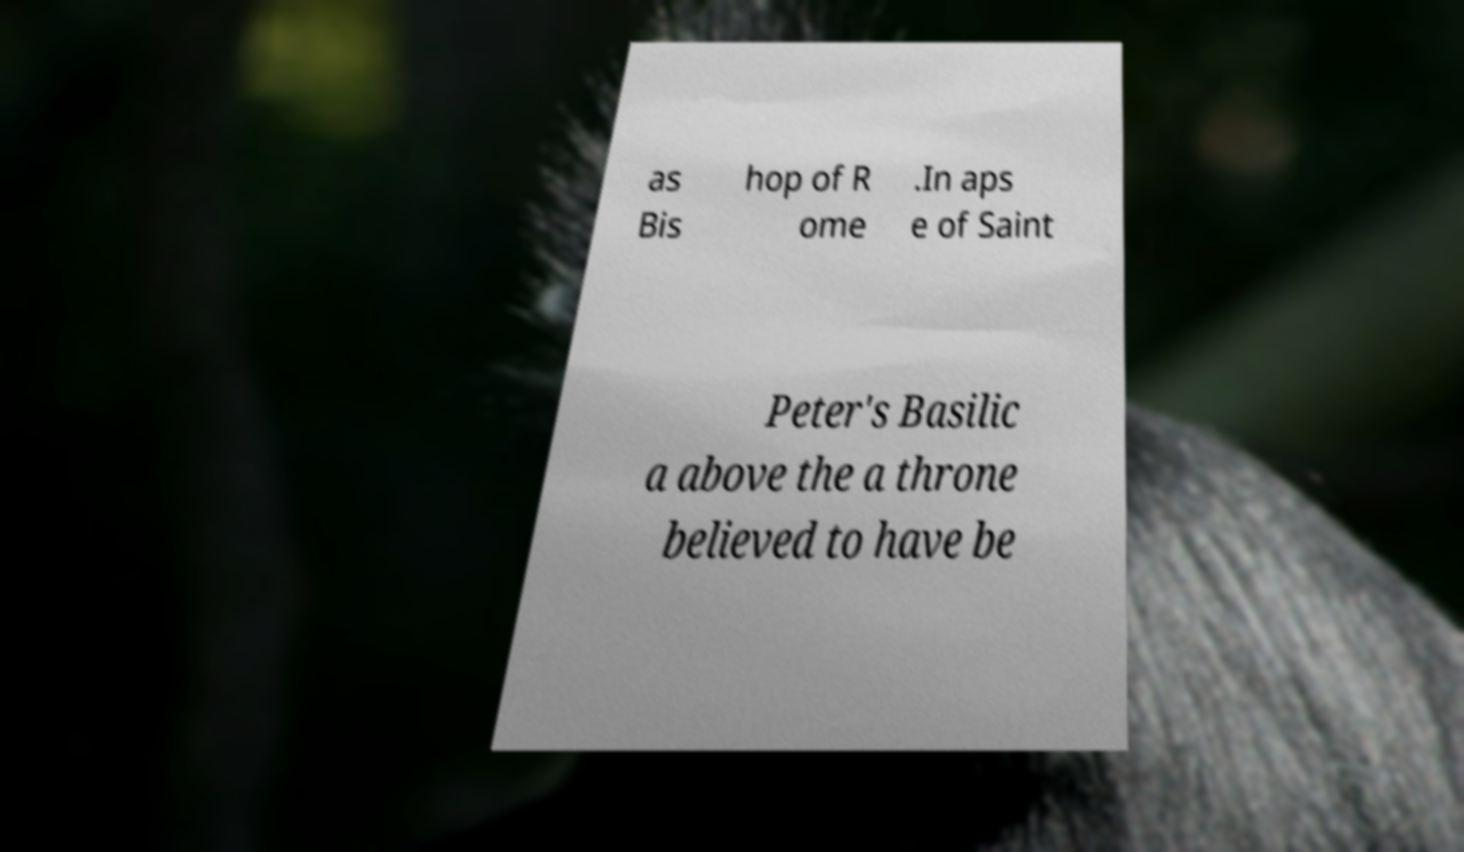There's text embedded in this image that I need extracted. Can you transcribe it verbatim? as Bis hop of R ome .In aps e of Saint Peter's Basilic a above the a throne believed to have be 